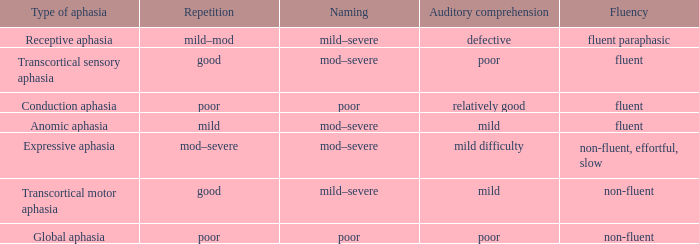State the apprehension for non-fluent, difficult, slow Mild difficulty. 